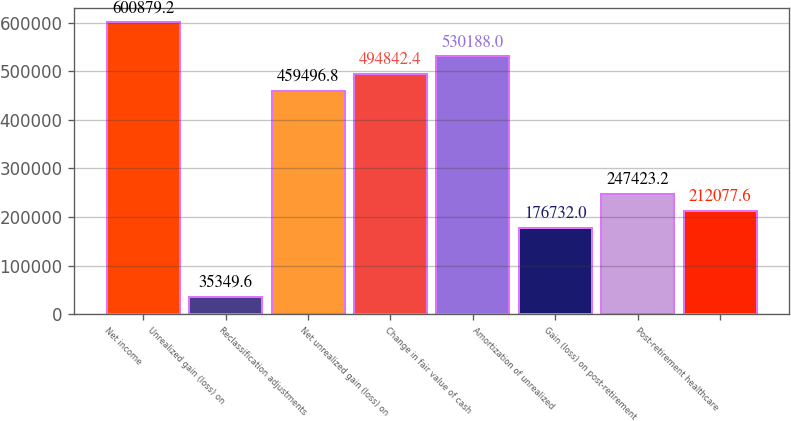<chart> <loc_0><loc_0><loc_500><loc_500><bar_chart><fcel>Net income<fcel>Unrealized gain (loss) on<fcel>Reclassification adjustments<fcel>Net unrealized gain (loss) on<fcel>Change in fair value of cash<fcel>Amortization of unrealized<fcel>Gain (loss) on post-retirement<fcel>Post-retirement healthcare<nl><fcel>600879<fcel>35349.6<fcel>459497<fcel>494842<fcel>530188<fcel>176732<fcel>247423<fcel>212078<nl></chart> 